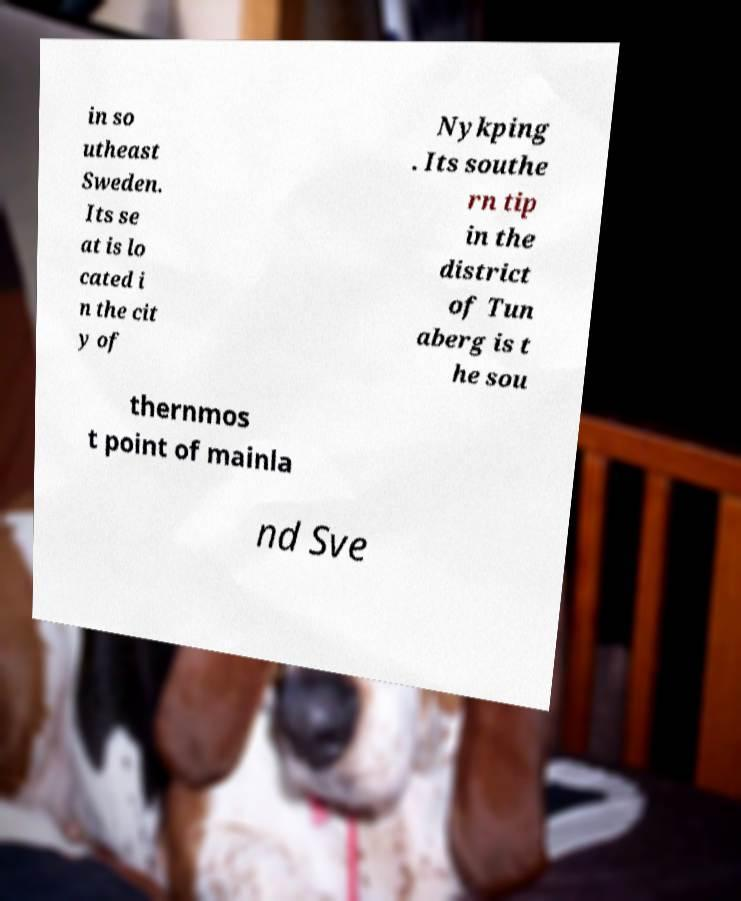Please read and relay the text visible in this image. What does it say? in so utheast Sweden. Its se at is lo cated i n the cit y of Nykping . Its southe rn tip in the district of Tun aberg is t he sou thernmos t point of mainla nd Sve 